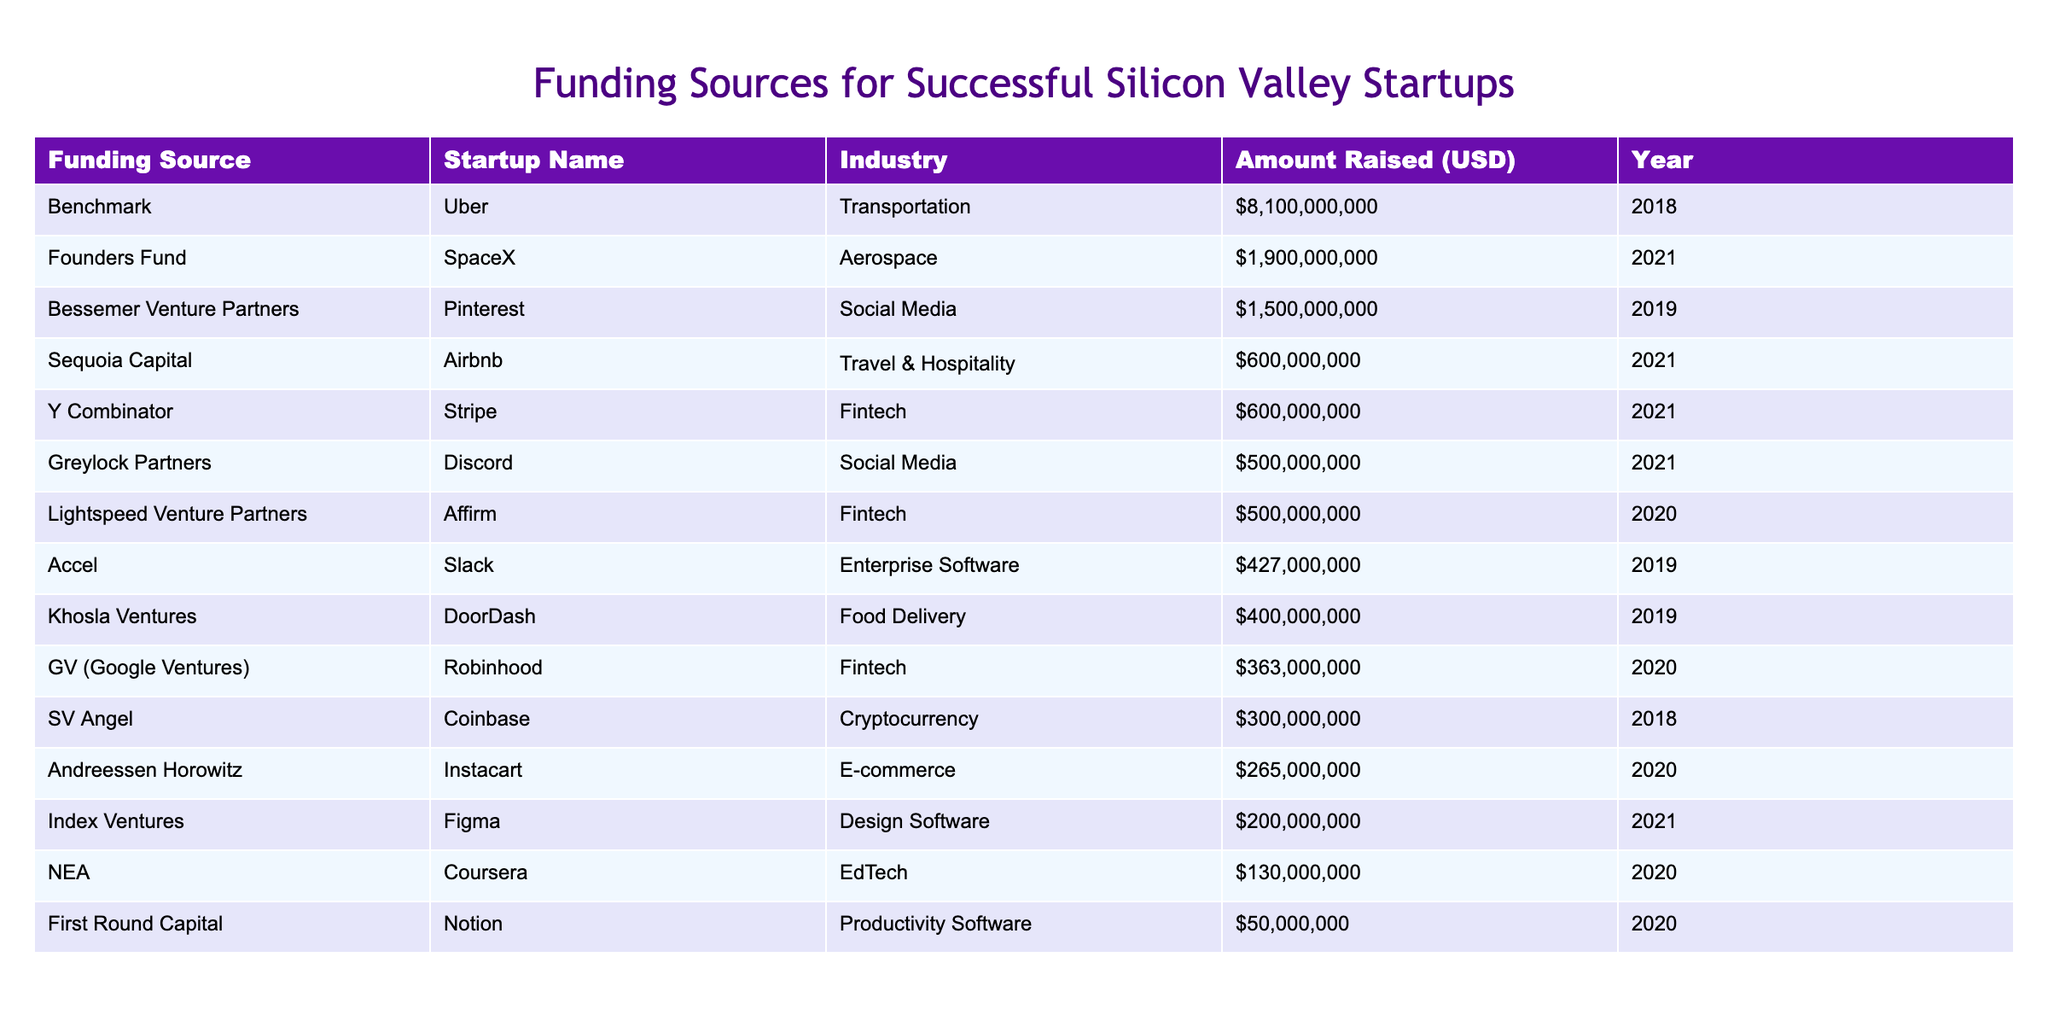What is the total amount raised by the startup Uber? The table shows that Uber raised a total of $8,100,000,000 in funding.
Answer: 8,100,000,000 Which startup received funding from Sequoia Capital? According to the table, Airbnb is the startup that received funding from Sequoia Capital.
Answer: Airbnb How many startups raised more than $500 million? By reviewing the amounts raised, the startups Uber, Airbnb, DoorDash, Stripe, Discord, SpaceX, and Pinterest raised more than $500 million. This totals 7 startups.
Answer: 7 What is the average amount raised by fintech startups listed in the table? The fintech startups listed are Stripe, Robinhood, and Affirm. Their amounts raised are $600,000,000, $363,000,000, and $500,000,000, which adds up to $1,463,000,000. Dividing by 3 gives an average of $487,666,667.
Answer: 487,666,667 Did Khosla Ventures fund any social media startups? The table indicates that Khosla Ventures funded DoorDash, which is in the food delivery industry, not a social media startup. Therefore, the answer is no.
Answer: No Which funding source had the highest contribution overall? Looking at the amounts raised, Benchmark provided the highest amount of $8,100,000,000 for Uber.
Answer: Benchmark What is the total funding amount for all listed startups in the E-commerce industry? The only startup in the E-commerce industry listed is Instacart, which raised $265,000,000. Since there is only one startup in this category, the total amount is simply $265,000,000.
Answer: 265,000,000 Which industry had the most funding sources represented in the table? Through analysis, the fintech industry is represented by three startups (Stripe, Robinhood, and Affirm), while other industries like food delivery, social media, and transportation have fewer representation.
Answer: Fintech Did Affirm raise more funding than SpaceX? From the data, Affirm raised $500,000,000 and SpaceX raised $1,900,000,000, making it clear that SpaceX raised more funding than Affirm. Therefore, the answer is no.
Answer: No 